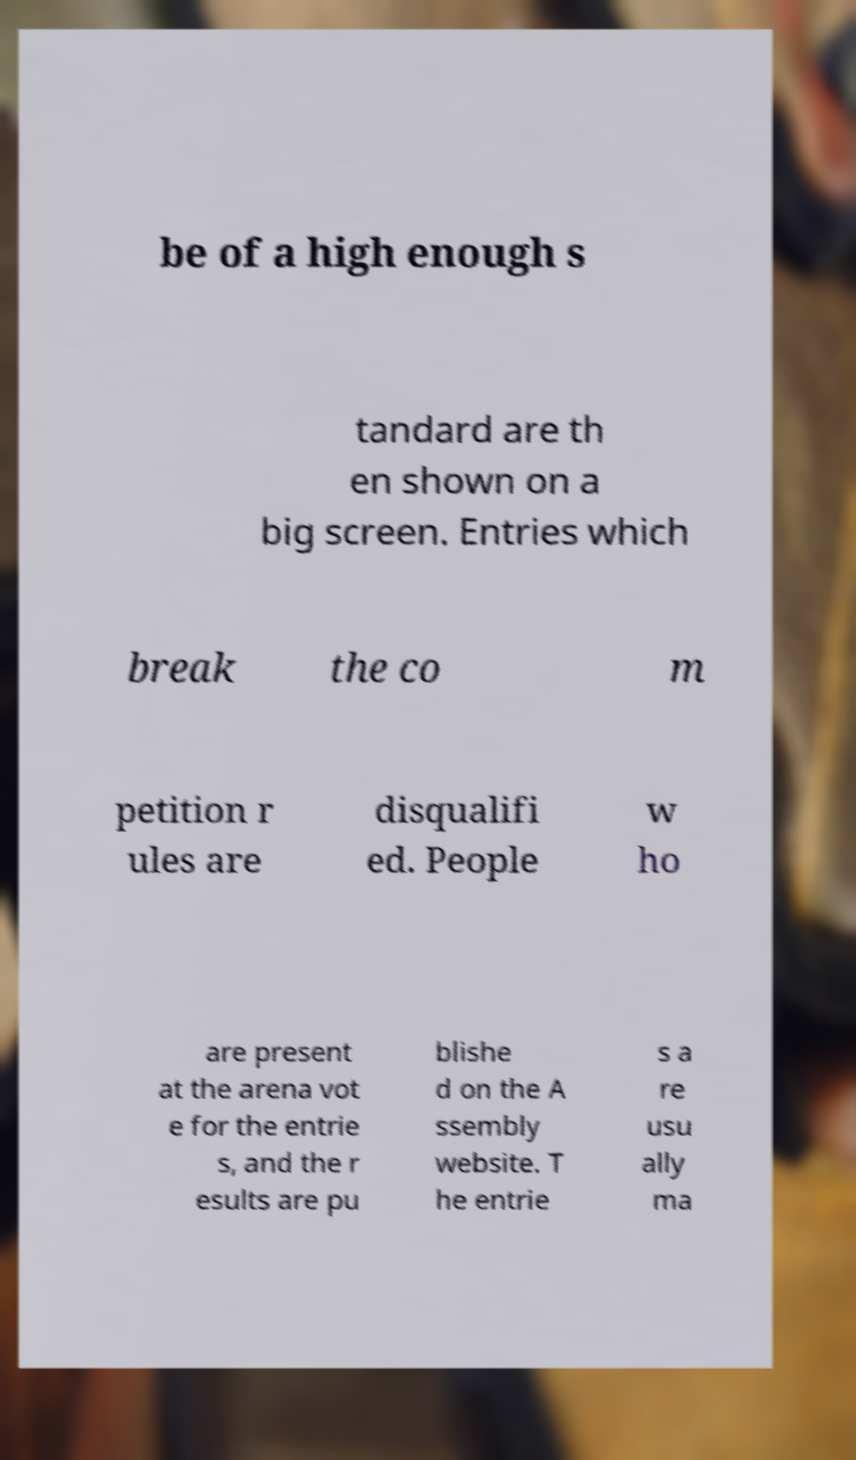Please identify and transcribe the text found in this image. be of a high enough s tandard are th en shown on a big screen. Entries which break the co m petition r ules are disqualifi ed. People w ho are present at the arena vot e for the entrie s, and the r esults are pu blishe d on the A ssembly website. T he entrie s a re usu ally ma 